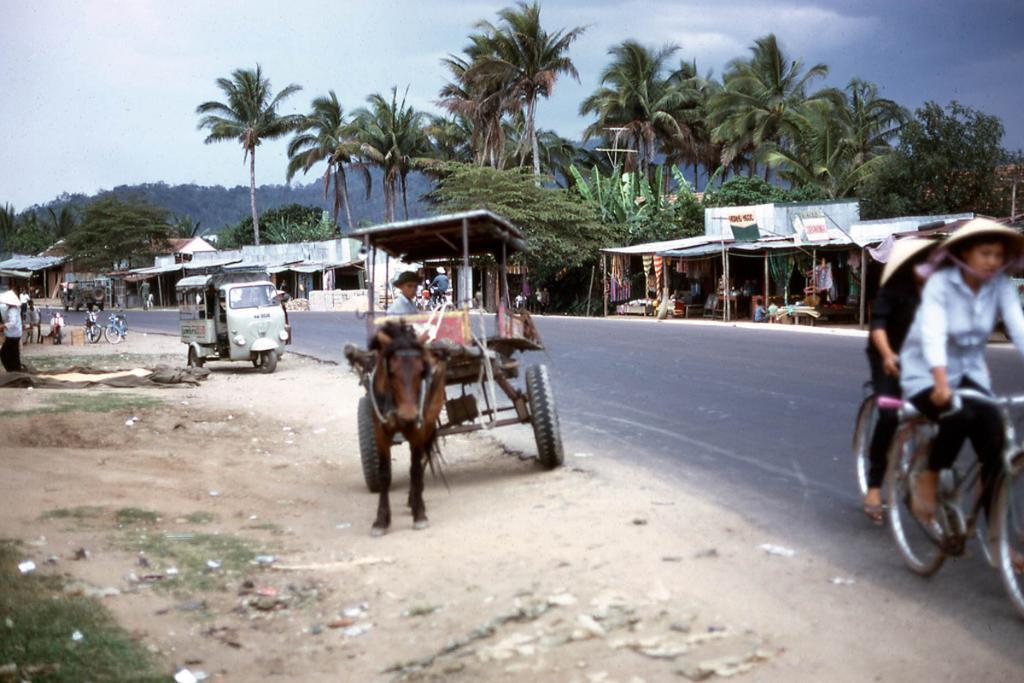Can you describe this image briefly? In this image there is a cart tied to a horse. A person is sitting inside the cart. Behind the cart there is a person riding the bicycle. Left side there are few vehicles on the land having some grass. Few persons are standing on the land. Right side two persons wearing caps are sitting and riding the bicycles on the road. Background there are few houses and shops. Behind there are few trees and hills. Top of the image there is sky with some clouds. 